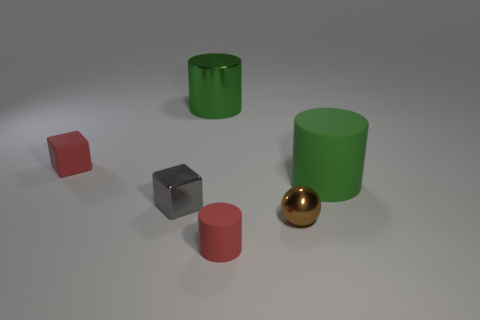There is a block that is the same color as the small rubber cylinder; what material is it? rubber 